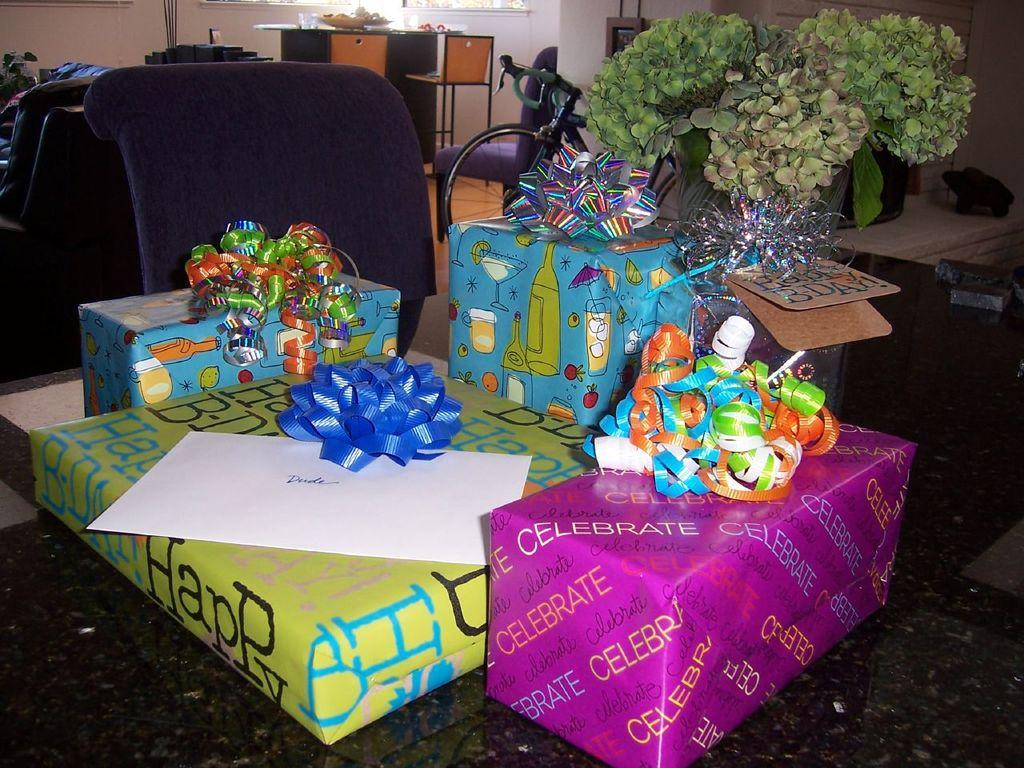What objects are present in the image that might be associated with a celebration or gift-giving? There are presents in the image. What type of furniture is visible in the image? There are chairs in the image. What mode of transportation can be seen in the image? There is a cycle in the image. What type of living organism is present in the image? There is a plant in the image. How many chairs are visible in the background of the image? There are two chairs visible in the background of the image. What type of architectural feature is present in the background of the image? There is a wall in the background of the image. What type of lip can be seen on the plant in the image? There is no lip present on the plant in the image. How does the sleet affect the visibility of the chairs in the image? There is no sleet present in the image, so it does not affect the visibility of the chairs. What type of wire is used to connect the cycle to the wall in the image? There is no wire connecting the cycle to the wall in the image. 